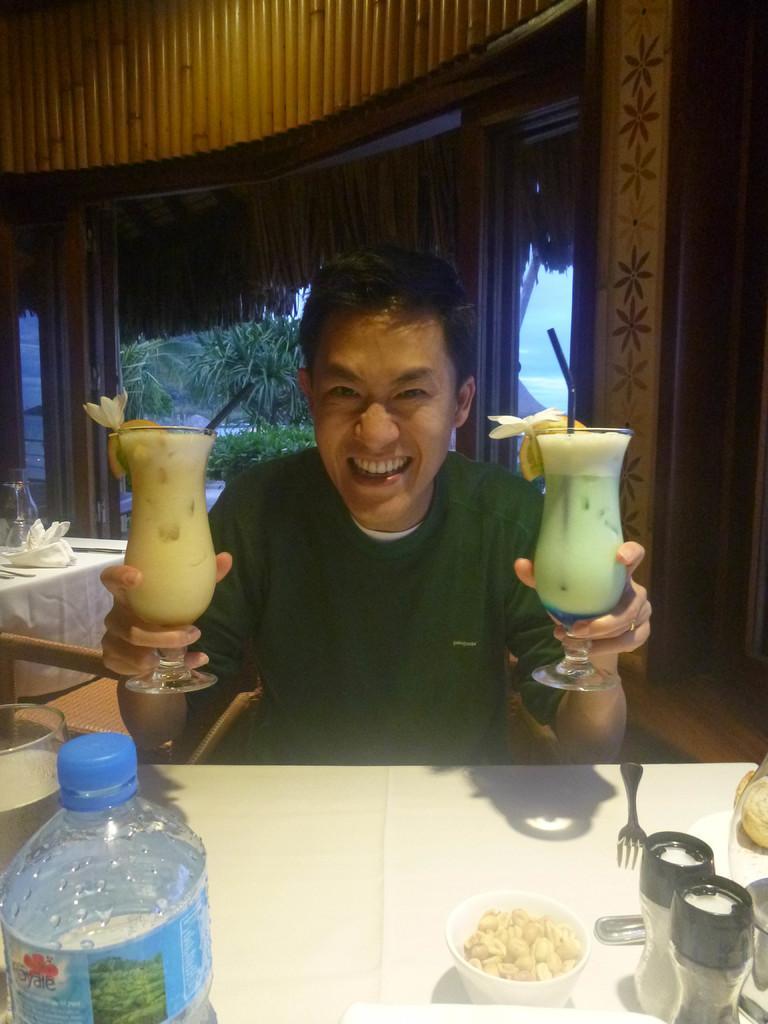Can you describe this image briefly? In this image i can see a person sit in front of a table and he holding a two glasses contain a juice and he is smiling , background of him there are some trees visible And there is a table on the left side , in front of the table There are the glasses and forks and food on the bowl kept on the table. 